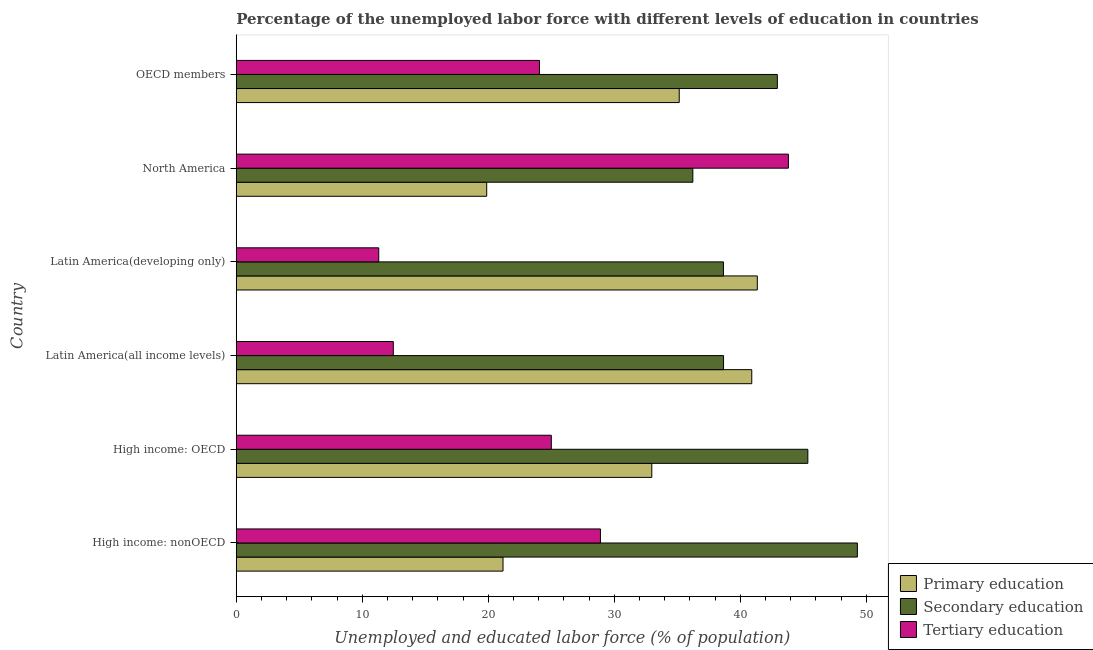How many groups of bars are there?
Provide a short and direct response. 6. Are the number of bars per tick equal to the number of legend labels?
Provide a succinct answer. Yes. Are the number of bars on each tick of the Y-axis equal?
Ensure brevity in your answer.  Yes. What is the label of the 5th group of bars from the top?
Ensure brevity in your answer.  High income: OECD. What is the percentage of labor force who received tertiary education in OECD members?
Your response must be concise. 24.06. Across all countries, what is the maximum percentage of labor force who received secondary education?
Provide a short and direct response. 49.28. Across all countries, what is the minimum percentage of labor force who received primary education?
Provide a short and direct response. 19.87. What is the total percentage of labor force who received primary education in the graph?
Offer a terse response. 191.41. What is the difference between the percentage of labor force who received secondary education in High income: OECD and that in North America?
Ensure brevity in your answer.  9.12. What is the difference between the percentage of labor force who received tertiary education in High income: OECD and the percentage of labor force who received primary education in OECD members?
Offer a very short reply. -10.15. What is the average percentage of labor force who received tertiary education per country?
Offer a very short reply. 24.26. What is the difference between the percentage of labor force who received primary education and percentage of labor force who received tertiary education in Latin America(all income levels)?
Offer a terse response. 28.44. In how many countries, is the percentage of labor force who received primary education greater than 22 %?
Make the answer very short. 4. What is the ratio of the percentage of labor force who received tertiary education in High income: nonOECD to that in OECD members?
Provide a succinct answer. 1.2. Is the difference between the percentage of labor force who received tertiary education in High income: nonOECD and Latin America(developing only) greater than the difference between the percentage of labor force who received primary education in High income: nonOECD and Latin America(developing only)?
Offer a terse response. Yes. What is the difference between the highest and the second highest percentage of labor force who received tertiary education?
Provide a succinct answer. 14.91. What is the difference between the highest and the lowest percentage of labor force who received secondary education?
Keep it short and to the point. 13.05. In how many countries, is the percentage of labor force who received tertiary education greater than the average percentage of labor force who received tertiary education taken over all countries?
Offer a very short reply. 3. Is the sum of the percentage of labor force who received tertiary education in Latin America(developing only) and North America greater than the maximum percentage of labor force who received secondary education across all countries?
Provide a succinct answer. Yes. What does the 1st bar from the top in North America represents?
Give a very brief answer. Tertiary education. What does the 2nd bar from the bottom in Latin America(all income levels) represents?
Provide a short and direct response. Secondary education. How many bars are there?
Provide a short and direct response. 18. How many countries are there in the graph?
Ensure brevity in your answer.  6. Does the graph contain any zero values?
Your response must be concise. No. Where does the legend appear in the graph?
Offer a very short reply. Bottom right. How many legend labels are there?
Keep it short and to the point. 3. What is the title of the graph?
Provide a short and direct response. Percentage of the unemployed labor force with different levels of education in countries. Does "Agriculture" appear as one of the legend labels in the graph?
Make the answer very short. No. What is the label or title of the X-axis?
Give a very brief answer. Unemployed and educated labor force (% of population). What is the label or title of the Y-axis?
Your answer should be compact. Country. What is the Unemployed and educated labor force (% of population) in Primary education in High income: nonOECD?
Ensure brevity in your answer.  21.17. What is the Unemployed and educated labor force (% of population) of Secondary education in High income: nonOECD?
Offer a terse response. 49.28. What is the Unemployed and educated labor force (% of population) in Tertiary education in High income: nonOECD?
Your response must be concise. 28.9. What is the Unemployed and educated labor force (% of population) of Primary education in High income: OECD?
Provide a succinct answer. 32.97. What is the Unemployed and educated labor force (% of population) in Secondary education in High income: OECD?
Provide a succinct answer. 45.35. What is the Unemployed and educated labor force (% of population) in Tertiary education in High income: OECD?
Ensure brevity in your answer.  25. What is the Unemployed and educated labor force (% of population) in Primary education in Latin America(all income levels)?
Ensure brevity in your answer.  40.9. What is the Unemployed and educated labor force (% of population) in Secondary education in Latin America(all income levels)?
Give a very brief answer. 38.66. What is the Unemployed and educated labor force (% of population) of Tertiary education in Latin America(all income levels)?
Your answer should be compact. 12.46. What is the Unemployed and educated labor force (% of population) of Primary education in Latin America(developing only)?
Your response must be concise. 41.34. What is the Unemployed and educated labor force (% of population) of Secondary education in Latin America(developing only)?
Your answer should be very brief. 38.66. What is the Unemployed and educated labor force (% of population) of Tertiary education in Latin America(developing only)?
Provide a short and direct response. 11.31. What is the Unemployed and educated labor force (% of population) of Primary education in North America?
Offer a very short reply. 19.87. What is the Unemployed and educated labor force (% of population) of Secondary education in North America?
Offer a terse response. 36.23. What is the Unemployed and educated labor force (% of population) in Tertiary education in North America?
Make the answer very short. 43.81. What is the Unemployed and educated labor force (% of population) in Primary education in OECD members?
Give a very brief answer. 35.15. What is the Unemployed and educated labor force (% of population) in Secondary education in OECD members?
Your answer should be compact. 42.93. What is the Unemployed and educated labor force (% of population) in Tertiary education in OECD members?
Offer a very short reply. 24.06. Across all countries, what is the maximum Unemployed and educated labor force (% of population) of Primary education?
Your response must be concise. 41.34. Across all countries, what is the maximum Unemployed and educated labor force (% of population) of Secondary education?
Provide a short and direct response. 49.28. Across all countries, what is the maximum Unemployed and educated labor force (% of population) in Tertiary education?
Your answer should be very brief. 43.81. Across all countries, what is the minimum Unemployed and educated labor force (% of population) in Primary education?
Keep it short and to the point. 19.87. Across all countries, what is the minimum Unemployed and educated labor force (% of population) of Secondary education?
Offer a terse response. 36.23. Across all countries, what is the minimum Unemployed and educated labor force (% of population) of Tertiary education?
Provide a succinct answer. 11.31. What is the total Unemployed and educated labor force (% of population) of Primary education in the graph?
Your response must be concise. 191.41. What is the total Unemployed and educated labor force (% of population) in Secondary education in the graph?
Give a very brief answer. 251.12. What is the total Unemployed and educated labor force (% of population) in Tertiary education in the graph?
Provide a succinct answer. 145.54. What is the difference between the Unemployed and educated labor force (% of population) in Primary education in High income: nonOECD and that in High income: OECD?
Your answer should be compact. -11.8. What is the difference between the Unemployed and educated labor force (% of population) of Secondary education in High income: nonOECD and that in High income: OECD?
Your answer should be compact. 3.93. What is the difference between the Unemployed and educated labor force (% of population) of Tertiary education in High income: nonOECD and that in High income: OECD?
Offer a very short reply. 3.9. What is the difference between the Unemployed and educated labor force (% of population) in Primary education in High income: nonOECD and that in Latin America(all income levels)?
Provide a short and direct response. -19.74. What is the difference between the Unemployed and educated labor force (% of population) of Secondary education in High income: nonOECD and that in Latin America(all income levels)?
Your response must be concise. 10.62. What is the difference between the Unemployed and educated labor force (% of population) of Tertiary education in High income: nonOECD and that in Latin America(all income levels)?
Provide a succinct answer. 16.44. What is the difference between the Unemployed and educated labor force (% of population) in Primary education in High income: nonOECD and that in Latin America(developing only)?
Your response must be concise. -20.18. What is the difference between the Unemployed and educated labor force (% of population) in Secondary education in High income: nonOECD and that in Latin America(developing only)?
Provide a short and direct response. 10.63. What is the difference between the Unemployed and educated labor force (% of population) of Tertiary education in High income: nonOECD and that in Latin America(developing only)?
Ensure brevity in your answer.  17.59. What is the difference between the Unemployed and educated labor force (% of population) of Primary education in High income: nonOECD and that in North America?
Provide a succinct answer. 1.3. What is the difference between the Unemployed and educated labor force (% of population) of Secondary education in High income: nonOECD and that in North America?
Provide a short and direct response. 13.05. What is the difference between the Unemployed and educated labor force (% of population) of Tertiary education in High income: nonOECD and that in North America?
Offer a terse response. -14.91. What is the difference between the Unemployed and educated labor force (% of population) in Primary education in High income: nonOECD and that in OECD members?
Your answer should be very brief. -13.98. What is the difference between the Unemployed and educated labor force (% of population) of Secondary education in High income: nonOECD and that in OECD members?
Your answer should be very brief. 6.35. What is the difference between the Unemployed and educated labor force (% of population) in Tertiary education in High income: nonOECD and that in OECD members?
Your answer should be compact. 4.84. What is the difference between the Unemployed and educated labor force (% of population) of Primary education in High income: OECD and that in Latin America(all income levels)?
Ensure brevity in your answer.  -7.93. What is the difference between the Unemployed and educated labor force (% of population) of Secondary education in High income: OECD and that in Latin America(all income levels)?
Your answer should be compact. 6.69. What is the difference between the Unemployed and educated labor force (% of population) of Tertiary education in High income: OECD and that in Latin America(all income levels)?
Provide a succinct answer. 12.54. What is the difference between the Unemployed and educated labor force (% of population) of Primary education in High income: OECD and that in Latin America(developing only)?
Provide a succinct answer. -8.37. What is the difference between the Unemployed and educated labor force (% of population) of Secondary education in High income: OECD and that in Latin America(developing only)?
Your answer should be compact. 6.7. What is the difference between the Unemployed and educated labor force (% of population) in Tertiary education in High income: OECD and that in Latin America(developing only)?
Keep it short and to the point. 13.69. What is the difference between the Unemployed and educated labor force (% of population) in Primary education in High income: OECD and that in North America?
Offer a very short reply. 13.1. What is the difference between the Unemployed and educated labor force (% of population) in Secondary education in High income: OECD and that in North America?
Make the answer very short. 9.12. What is the difference between the Unemployed and educated labor force (% of population) in Tertiary education in High income: OECD and that in North America?
Provide a short and direct response. -18.81. What is the difference between the Unemployed and educated labor force (% of population) of Primary education in High income: OECD and that in OECD members?
Offer a terse response. -2.18. What is the difference between the Unemployed and educated labor force (% of population) in Secondary education in High income: OECD and that in OECD members?
Your response must be concise. 2.42. What is the difference between the Unemployed and educated labor force (% of population) of Primary education in Latin America(all income levels) and that in Latin America(developing only)?
Keep it short and to the point. -0.44. What is the difference between the Unemployed and educated labor force (% of population) of Secondary education in Latin America(all income levels) and that in Latin America(developing only)?
Your answer should be very brief. 0.01. What is the difference between the Unemployed and educated labor force (% of population) of Tertiary education in Latin America(all income levels) and that in Latin America(developing only)?
Make the answer very short. 1.16. What is the difference between the Unemployed and educated labor force (% of population) in Primary education in Latin America(all income levels) and that in North America?
Ensure brevity in your answer.  21.03. What is the difference between the Unemployed and educated labor force (% of population) of Secondary education in Latin America(all income levels) and that in North America?
Ensure brevity in your answer.  2.44. What is the difference between the Unemployed and educated labor force (% of population) of Tertiary education in Latin America(all income levels) and that in North America?
Make the answer very short. -31.35. What is the difference between the Unemployed and educated labor force (% of population) in Primary education in Latin America(all income levels) and that in OECD members?
Keep it short and to the point. 5.76. What is the difference between the Unemployed and educated labor force (% of population) of Secondary education in Latin America(all income levels) and that in OECD members?
Your response must be concise. -4.27. What is the difference between the Unemployed and educated labor force (% of population) in Tertiary education in Latin America(all income levels) and that in OECD members?
Your response must be concise. -11.6. What is the difference between the Unemployed and educated labor force (% of population) in Primary education in Latin America(developing only) and that in North America?
Provide a succinct answer. 21.47. What is the difference between the Unemployed and educated labor force (% of population) in Secondary education in Latin America(developing only) and that in North America?
Your response must be concise. 2.43. What is the difference between the Unemployed and educated labor force (% of population) in Tertiary education in Latin America(developing only) and that in North America?
Your answer should be compact. -32.51. What is the difference between the Unemployed and educated labor force (% of population) in Primary education in Latin America(developing only) and that in OECD members?
Provide a succinct answer. 6.19. What is the difference between the Unemployed and educated labor force (% of population) in Secondary education in Latin America(developing only) and that in OECD members?
Offer a very short reply. -4.28. What is the difference between the Unemployed and educated labor force (% of population) of Tertiary education in Latin America(developing only) and that in OECD members?
Your answer should be very brief. -12.75. What is the difference between the Unemployed and educated labor force (% of population) in Primary education in North America and that in OECD members?
Your response must be concise. -15.28. What is the difference between the Unemployed and educated labor force (% of population) in Secondary education in North America and that in OECD members?
Provide a succinct answer. -6.7. What is the difference between the Unemployed and educated labor force (% of population) of Tertiary education in North America and that in OECD members?
Give a very brief answer. 19.75. What is the difference between the Unemployed and educated labor force (% of population) of Primary education in High income: nonOECD and the Unemployed and educated labor force (% of population) of Secondary education in High income: OECD?
Provide a short and direct response. -24.19. What is the difference between the Unemployed and educated labor force (% of population) of Primary education in High income: nonOECD and the Unemployed and educated labor force (% of population) of Tertiary education in High income: OECD?
Keep it short and to the point. -3.83. What is the difference between the Unemployed and educated labor force (% of population) of Secondary education in High income: nonOECD and the Unemployed and educated labor force (% of population) of Tertiary education in High income: OECD?
Ensure brevity in your answer.  24.28. What is the difference between the Unemployed and educated labor force (% of population) of Primary education in High income: nonOECD and the Unemployed and educated labor force (% of population) of Secondary education in Latin America(all income levels)?
Give a very brief answer. -17.5. What is the difference between the Unemployed and educated labor force (% of population) of Primary education in High income: nonOECD and the Unemployed and educated labor force (% of population) of Tertiary education in Latin America(all income levels)?
Provide a succinct answer. 8.71. What is the difference between the Unemployed and educated labor force (% of population) of Secondary education in High income: nonOECD and the Unemployed and educated labor force (% of population) of Tertiary education in Latin America(all income levels)?
Make the answer very short. 36.82. What is the difference between the Unemployed and educated labor force (% of population) of Primary education in High income: nonOECD and the Unemployed and educated labor force (% of population) of Secondary education in Latin America(developing only)?
Keep it short and to the point. -17.49. What is the difference between the Unemployed and educated labor force (% of population) in Primary education in High income: nonOECD and the Unemployed and educated labor force (% of population) in Tertiary education in Latin America(developing only)?
Keep it short and to the point. 9.86. What is the difference between the Unemployed and educated labor force (% of population) in Secondary education in High income: nonOECD and the Unemployed and educated labor force (% of population) in Tertiary education in Latin America(developing only)?
Provide a succinct answer. 37.98. What is the difference between the Unemployed and educated labor force (% of population) in Primary education in High income: nonOECD and the Unemployed and educated labor force (% of population) in Secondary education in North America?
Your answer should be compact. -15.06. What is the difference between the Unemployed and educated labor force (% of population) of Primary education in High income: nonOECD and the Unemployed and educated labor force (% of population) of Tertiary education in North America?
Provide a short and direct response. -22.64. What is the difference between the Unemployed and educated labor force (% of population) of Secondary education in High income: nonOECD and the Unemployed and educated labor force (% of population) of Tertiary education in North America?
Your answer should be very brief. 5.47. What is the difference between the Unemployed and educated labor force (% of population) in Primary education in High income: nonOECD and the Unemployed and educated labor force (% of population) in Secondary education in OECD members?
Offer a very short reply. -21.77. What is the difference between the Unemployed and educated labor force (% of population) of Primary education in High income: nonOECD and the Unemployed and educated labor force (% of population) of Tertiary education in OECD members?
Offer a very short reply. -2.89. What is the difference between the Unemployed and educated labor force (% of population) of Secondary education in High income: nonOECD and the Unemployed and educated labor force (% of population) of Tertiary education in OECD members?
Your answer should be very brief. 25.22. What is the difference between the Unemployed and educated labor force (% of population) of Primary education in High income: OECD and the Unemployed and educated labor force (% of population) of Secondary education in Latin America(all income levels)?
Ensure brevity in your answer.  -5.69. What is the difference between the Unemployed and educated labor force (% of population) in Primary education in High income: OECD and the Unemployed and educated labor force (% of population) in Tertiary education in Latin America(all income levels)?
Provide a short and direct response. 20.51. What is the difference between the Unemployed and educated labor force (% of population) of Secondary education in High income: OECD and the Unemployed and educated labor force (% of population) of Tertiary education in Latin America(all income levels)?
Offer a very short reply. 32.89. What is the difference between the Unemployed and educated labor force (% of population) in Primary education in High income: OECD and the Unemployed and educated labor force (% of population) in Secondary education in Latin America(developing only)?
Provide a short and direct response. -5.68. What is the difference between the Unemployed and educated labor force (% of population) in Primary education in High income: OECD and the Unemployed and educated labor force (% of population) in Tertiary education in Latin America(developing only)?
Keep it short and to the point. 21.67. What is the difference between the Unemployed and educated labor force (% of population) in Secondary education in High income: OECD and the Unemployed and educated labor force (% of population) in Tertiary education in Latin America(developing only)?
Give a very brief answer. 34.05. What is the difference between the Unemployed and educated labor force (% of population) of Primary education in High income: OECD and the Unemployed and educated labor force (% of population) of Secondary education in North America?
Give a very brief answer. -3.26. What is the difference between the Unemployed and educated labor force (% of population) of Primary education in High income: OECD and the Unemployed and educated labor force (% of population) of Tertiary education in North America?
Offer a very short reply. -10.84. What is the difference between the Unemployed and educated labor force (% of population) of Secondary education in High income: OECD and the Unemployed and educated labor force (% of population) of Tertiary education in North America?
Offer a terse response. 1.54. What is the difference between the Unemployed and educated labor force (% of population) of Primary education in High income: OECD and the Unemployed and educated labor force (% of population) of Secondary education in OECD members?
Your response must be concise. -9.96. What is the difference between the Unemployed and educated labor force (% of population) in Primary education in High income: OECD and the Unemployed and educated labor force (% of population) in Tertiary education in OECD members?
Provide a short and direct response. 8.91. What is the difference between the Unemployed and educated labor force (% of population) in Secondary education in High income: OECD and the Unemployed and educated labor force (% of population) in Tertiary education in OECD members?
Offer a terse response. 21.29. What is the difference between the Unemployed and educated labor force (% of population) of Primary education in Latin America(all income levels) and the Unemployed and educated labor force (% of population) of Secondary education in Latin America(developing only)?
Offer a terse response. 2.25. What is the difference between the Unemployed and educated labor force (% of population) of Primary education in Latin America(all income levels) and the Unemployed and educated labor force (% of population) of Tertiary education in Latin America(developing only)?
Provide a succinct answer. 29.6. What is the difference between the Unemployed and educated labor force (% of population) of Secondary education in Latin America(all income levels) and the Unemployed and educated labor force (% of population) of Tertiary education in Latin America(developing only)?
Make the answer very short. 27.36. What is the difference between the Unemployed and educated labor force (% of population) in Primary education in Latin America(all income levels) and the Unemployed and educated labor force (% of population) in Secondary education in North America?
Ensure brevity in your answer.  4.68. What is the difference between the Unemployed and educated labor force (% of population) of Primary education in Latin America(all income levels) and the Unemployed and educated labor force (% of population) of Tertiary education in North America?
Your answer should be compact. -2.91. What is the difference between the Unemployed and educated labor force (% of population) of Secondary education in Latin America(all income levels) and the Unemployed and educated labor force (% of population) of Tertiary education in North America?
Offer a very short reply. -5.15. What is the difference between the Unemployed and educated labor force (% of population) of Primary education in Latin America(all income levels) and the Unemployed and educated labor force (% of population) of Secondary education in OECD members?
Make the answer very short. -2.03. What is the difference between the Unemployed and educated labor force (% of population) of Primary education in Latin America(all income levels) and the Unemployed and educated labor force (% of population) of Tertiary education in OECD members?
Your answer should be very brief. 16.84. What is the difference between the Unemployed and educated labor force (% of population) in Secondary education in Latin America(all income levels) and the Unemployed and educated labor force (% of population) in Tertiary education in OECD members?
Your answer should be very brief. 14.61. What is the difference between the Unemployed and educated labor force (% of population) in Primary education in Latin America(developing only) and the Unemployed and educated labor force (% of population) in Secondary education in North America?
Offer a very short reply. 5.11. What is the difference between the Unemployed and educated labor force (% of population) of Primary education in Latin America(developing only) and the Unemployed and educated labor force (% of population) of Tertiary education in North America?
Ensure brevity in your answer.  -2.47. What is the difference between the Unemployed and educated labor force (% of population) in Secondary education in Latin America(developing only) and the Unemployed and educated labor force (% of population) in Tertiary education in North America?
Your response must be concise. -5.16. What is the difference between the Unemployed and educated labor force (% of population) of Primary education in Latin America(developing only) and the Unemployed and educated labor force (% of population) of Secondary education in OECD members?
Provide a short and direct response. -1.59. What is the difference between the Unemployed and educated labor force (% of population) of Primary education in Latin America(developing only) and the Unemployed and educated labor force (% of population) of Tertiary education in OECD members?
Offer a terse response. 17.28. What is the difference between the Unemployed and educated labor force (% of population) in Secondary education in Latin America(developing only) and the Unemployed and educated labor force (% of population) in Tertiary education in OECD members?
Your response must be concise. 14.6. What is the difference between the Unemployed and educated labor force (% of population) in Primary education in North America and the Unemployed and educated labor force (% of population) in Secondary education in OECD members?
Provide a short and direct response. -23.06. What is the difference between the Unemployed and educated labor force (% of population) of Primary education in North America and the Unemployed and educated labor force (% of population) of Tertiary education in OECD members?
Keep it short and to the point. -4.19. What is the difference between the Unemployed and educated labor force (% of population) in Secondary education in North America and the Unemployed and educated labor force (% of population) in Tertiary education in OECD members?
Make the answer very short. 12.17. What is the average Unemployed and educated labor force (% of population) in Primary education per country?
Your answer should be very brief. 31.9. What is the average Unemployed and educated labor force (% of population) in Secondary education per country?
Offer a very short reply. 41.85. What is the average Unemployed and educated labor force (% of population) of Tertiary education per country?
Give a very brief answer. 24.26. What is the difference between the Unemployed and educated labor force (% of population) in Primary education and Unemployed and educated labor force (% of population) in Secondary education in High income: nonOECD?
Provide a short and direct response. -28.12. What is the difference between the Unemployed and educated labor force (% of population) of Primary education and Unemployed and educated labor force (% of population) of Tertiary education in High income: nonOECD?
Offer a terse response. -7.73. What is the difference between the Unemployed and educated labor force (% of population) of Secondary education and Unemployed and educated labor force (% of population) of Tertiary education in High income: nonOECD?
Your response must be concise. 20.39. What is the difference between the Unemployed and educated labor force (% of population) in Primary education and Unemployed and educated labor force (% of population) in Secondary education in High income: OECD?
Ensure brevity in your answer.  -12.38. What is the difference between the Unemployed and educated labor force (% of population) of Primary education and Unemployed and educated labor force (% of population) of Tertiary education in High income: OECD?
Give a very brief answer. 7.97. What is the difference between the Unemployed and educated labor force (% of population) of Secondary education and Unemployed and educated labor force (% of population) of Tertiary education in High income: OECD?
Provide a short and direct response. 20.35. What is the difference between the Unemployed and educated labor force (% of population) in Primary education and Unemployed and educated labor force (% of population) in Secondary education in Latin America(all income levels)?
Ensure brevity in your answer.  2.24. What is the difference between the Unemployed and educated labor force (% of population) of Primary education and Unemployed and educated labor force (% of population) of Tertiary education in Latin America(all income levels)?
Keep it short and to the point. 28.44. What is the difference between the Unemployed and educated labor force (% of population) in Secondary education and Unemployed and educated labor force (% of population) in Tertiary education in Latin America(all income levels)?
Make the answer very short. 26.2. What is the difference between the Unemployed and educated labor force (% of population) in Primary education and Unemployed and educated labor force (% of population) in Secondary education in Latin America(developing only)?
Your answer should be compact. 2.69. What is the difference between the Unemployed and educated labor force (% of population) of Primary education and Unemployed and educated labor force (% of population) of Tertiary education in Latin America(developing only)?
Your answer should be very brief. 30.04. What is the difference between the Unemployed and educated labor force (% of population) in Secondary education and Unemployed and educated labor force (% of population) in Tertiary education in Latin America(developing only)?
Your answer should be compact. 27.35. What is the difference between the Unemployed and educated labor force (% of population) in Primary education and Unemployed and educated labor force (% of population) in Secondary education in North America?
Give a very brief answer. -16.36. What is the difference between the Unemployed and educated labor force (% of population) of Primary education and Unemployed and educated labor force (% of population) of Tertiary education in North America?
Provide a succinct answer. -23.94. What is the difference between the Unemployed and educated labor force (% of population) of Secondary education and Unemployed and educated labor force (% of population) of Tertiary education in North America?
Offer a very short reply. -7.58. What is the difference between the Unemployed and educated labor force (% of population) of Primary education and Unemployed and educated labor force (% of population) of Secondary education in OECD members?
Make the answer very short. -7.78. What is the difference between the Unemployed and educated labor force (% of population) in Primary education and Unemployed and educated labor force (% of population) in Tertiary education in OECD members?
Provide a short and direct response. 11.09. What is the difference between the Unemployed and educated labor force (% of population) in Secondary education and Unemployed and educated labor force (% of population) in Tertiary education in OECD members?
Make the answer very short. 18.87. What is the ratio of the Unemployed and educated labor force (% of population) in Primary education in High income: nonOECD to that in High income: OECD?
Your answer should be very brief. 0.64. What is the ratio of the Unemployed and educated labor force (% of population) of Secondary education in High income: nonOECD to that in High income: OECD?
Offer a very short reply. 1.09. What is the ratio of the Unemployed and educated labor force (% of population) in Tertiary education in High income: nonOECD to that in High income: OECD?
Give a very brief answer. 1.16. What is the ratio of the Unemployed and educated labor force (% of population) of Primary education in High income: nonOECD to that in Latin America(all income levels)?
Ensure brevity in your answer.  0.52. What is the ratio of the Unemployed and educated labor force (% of population) of Secondary education in High income: nonOECD to that in Latin America(all income levels)?
Provide a succinct answer. 1.27. What is the ratio of the Unemployed and educated labor force (% of population) of Tertiary education in High income: nonOECD to that in Latin America(all income levels)?
Keep it short and to the point. 2.32. What is the ratio of the Unemployed and educated labor force (% of population) in Primary education in High income: nonOECD to that in Latin America(developing only)?
Your answer should be compact. 0.51. What is the ratio of the Unemployed and educated labor force (% of population) of Secondary education in High income: nonOECD to that in Latin America(developing only)?
Give a very brief answer. 1.27. What is the ratio of the Unemployed and educated labor force (% of population) of Tertiary education in High income: nonOECD to that in Latin America(developing only)?
Offer a very short reply. 2.56. What is the ratio of the Unemployed and educated labor force (% of population) in Primary education in High income: nonOECD to that in North America?
Make the answer very short. 1.07. What is the ratio of the Unemployed and educated labor force (% of population) in Secondary education in High income: nonOECD to that in North America?
Your response must be concise. 1.36. What is the ratio of the Unemployed and educated labor force (% of population) in Tertiary education in High income: nonOECD to that in North America?
Your answer should be compact. 0.66. What is the ratio of the Unemployed and educated labor force (% of population) of Primary education in High income: nonOECD to that in OECD members?
Provide a succinct answer. 0.6. What is the ratio of the Unemployed and educated labor force (% of population) in Secondary education in High income: nonOECD to that in OECD members?
Your answer should be compact. 1.15. What is the ratio of the Unemployed and educated labor force (% of population) of Tertiary education in High income: nonOECD to that in OECD members?
Your response must be concise. 1.2. What is the ratio of the Unemployed and educated labor force (% of population) of Primary education in High income: OECD to that in Latin America(all income levels)?
Your response must be concise. 0.81. What is the ratio of the Unemployed and educated labor force (% of population) of Secondary education in High income: OECD to that in Latin America(all income levels)?
Your answer should be compact. 1.17. What is the ratio of the Unemployed and educated labor force (% of population) in Tertiary education in High income: OECD to that in Latin America(all income levels)?
Offer a terse response. 2.01. What is the ratio of the Unemployed and educated labor force (% of population) in Primary education in High income: OECD to that in Latin America(developing only)?
Provide a succinct answer. 0.8. What is the ratio of the Unemployed and educated labor force (% of population) in Secondary education in High income: OECD to that in Latin America(developing only)?
Your response must be concise. 1.17. What is the ratio of the Unemployed and educated labor force (% of population) in Tertiary education in High income: OECD to that in Latin America(developing only)?
Keep it short and to the point. 2.21. What is the ratio of the Unemployed and educated labor force (% of population) of Primary education in High income: OECD to that in North America?
Give a very brief answer. 1.66. What is the ratio of the Unemployed and educated labor force (% of population) in Secondary education in High income: OECD to that in North America?
Give a very brief answer. 1.25. What is the ratio of the Unemployed and educated labor force (% of population) of Tertiary education in High income: OECD to that in North America?
Offer a terse response. 0.57. What is the ratio of the Unemployed and educated labor force (% of population) in Primary education in High income: OECD to that in OECD members?
Provide a succinct answer. 0.94. What is the ratio of the Unemployed and educated labor force (% of population) in Secondary education in High income: OECD to that in OECD members?
Keep it short and to the point. 1.06. What is the ratio of the Unemployed and educated labor force (% of population) in Tertiary education in High income: OECD to that in OECD members?
Your answer should be very brief. 1.04. What is the ratio of the Unemployed and educated labor force (% of population) of Primary education in Latin America(all income levels) to that in Latin America(developing only)?
Offer a terse response. 0.99. What is the ratio of the Unemployed and educated labor force (% of population) in Tertiary education in Latin America(all income levels) to that in Latin America(developing only)?
Your response must be concise. 1.1. What is the ratio of the Unemployed and educated labor force (% of population) of Primary education in Latin America(all income levels) to that in North America?
Give a very brief answer. 2.06. What is the ratio of the Unemployed and educated labor force (% of population) in Secondary education in Latin America(all income levels) to that in North America?
Ensure brevity in your answer.  1.07. What is the ratio of the Unemployed and educated labor force (% of population) of Tertiary education in Latin America(all income levels) to that in North America?
Make the answer very short. 0.28. What is the ratio of the Unemployed and educated labor force (% of population) of Primary education in Latin America(all income levels) to that in OECD members?
Give a very brief answer. 1.16. What is the ratio of the Unemployed and educated labor force (% of population) of Secondary education in Latin America(all income levels) to that in OECD members?
Your answer should be compact. 0.9. What is the ratio of the Unemployed and educated labor force (% of population) in Tertiary education in Latin America(all income levels) to that in OECD members?
Your response must be concise. 0.52. What is the ratio of the Unemployed and educated labor force (% of population) in Primary education in Latin America(developing only) to that in North America?
Give a very brief answer. 2.08. What is the ratio of the Unemployed and educated labor force (% of population) of Secondary education in Latin America(developing only) to that in North America?
Make the answer very short. 1.07. What is the ratio of the Unemployed and educated labor force (% of population) of Tertiary education in Latin America(developing only) to that in North America?
Provide a succinct answer. 0.26. What is the ratio of the Unemployed and educated labor force (% of population) of Primary education in Latin America(developing only) to that in OECD members?
Provide a short and direct response. 1.18. What is the ratio of the Unemployed and educated labor force (% of population) of Secondary education in Latin America(developing only) to that in OECD members?
Offer a terse response. 0.9. What is the ratio of the Unemployed and educated labor force (% of population) of Tertiary education in Latin America(developing only) to that in OECD members?
Make the answer very short. 0.47. What is the ratio of the Unemployed and educated labor force (% of population) of Primary education in North America to that in OECD members?
Provide a short and direct response. 0.57. What is the ratio of the Unemployed and educated labor force (% of population) in Secondary education in North America to that in OECD members?
Your answer should be very brief. 0.84. What is the ratio of the Unemployed and educated labor force (% of population) of Tertiary education in North America to that in OECD members?
Give a very brief answer. 1.82. What is the difference between the highest and the second highest Unemployed and educated labor force (% of population) in Primary education?
Offer a very short reply. 0.44. What is the difference between the highest and the second highest Unemployed and educated labor force (% of population) of Secondary education?
Your response must be concise. 3.93. What is the difference between the highest and the second highest Unemployed and educated labor force (% of population) in Tertiary education?
Your answer should be very brief. 14.91. What is the difference between the highest and the lowest Unemployed and educated labor force (% of population) of Primary education?
Your response must be concise. 21.47. What is the difference between the highest and the lowest Unemployed and educated labor force (% of population) in Secondary education?
Offer a very short reply. 13.05. What is the difference between the highest and the lowest Unemployed and educated labor force (% of population) of Tertiary education?
Make the answer very short. 32.51. 